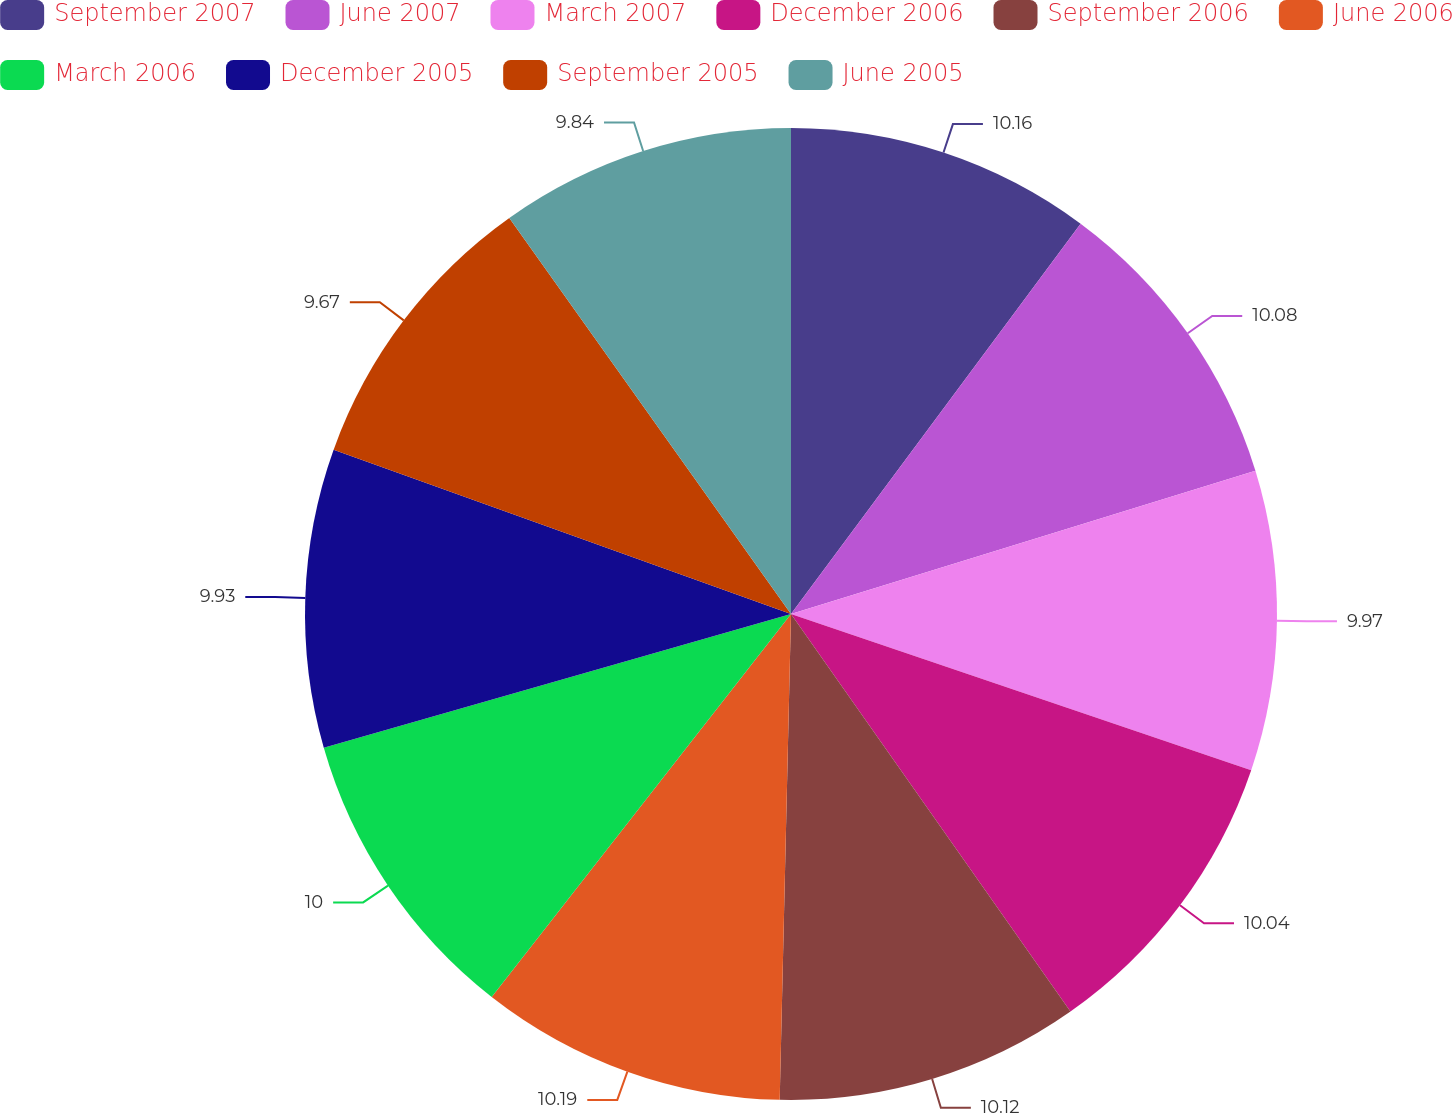<chart> <loc_0><loc_0><loc_500><loc_500><pie_chart><fcel>September 2007<fcel>June 2007<fcel>March 2007<fcel>December 2006<fcel>September 2006<fcel>June 2006<fcel>March 2006<fcel>December 2005<fcel>September 2005<fcel>June 2005<nl><fcel>10.16%<fcel>10.08%<fcel>9.97%<fcel>10.04%<fcel>10.12%<fcel>10.19%<fcel>10.0%<fcel>9.93%<fcel>9.67%<fcel>9.84%<nl></chart> 